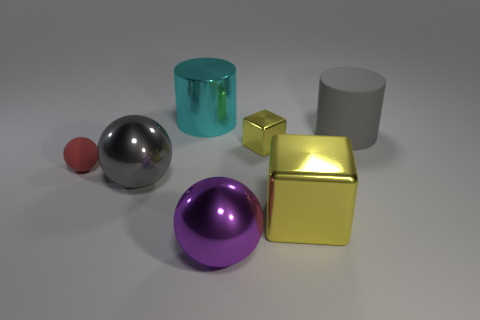Subtract all big metal spheres. How many spheres are left? 1 Add 2 tiny cyan metal blocks. How many objects exist? 9 Subtract all purple balls. How many balls are left? 2 Subtract 1 cylinders. How many cylinders are left? 1 Subtract all cylinders. How many objects are left? 5 Subtract all blue cylinders. How many blue cubes are left? 0 Subtract all small red balls. Subtract all red rubber things. How many objects are left? 5 Add 4 big cylinders. How many big cylinders are left? 6 Add 7 purple things. How many purple things exist? 8 Subtract 0 cyan cubes. How many objects are left? 7 